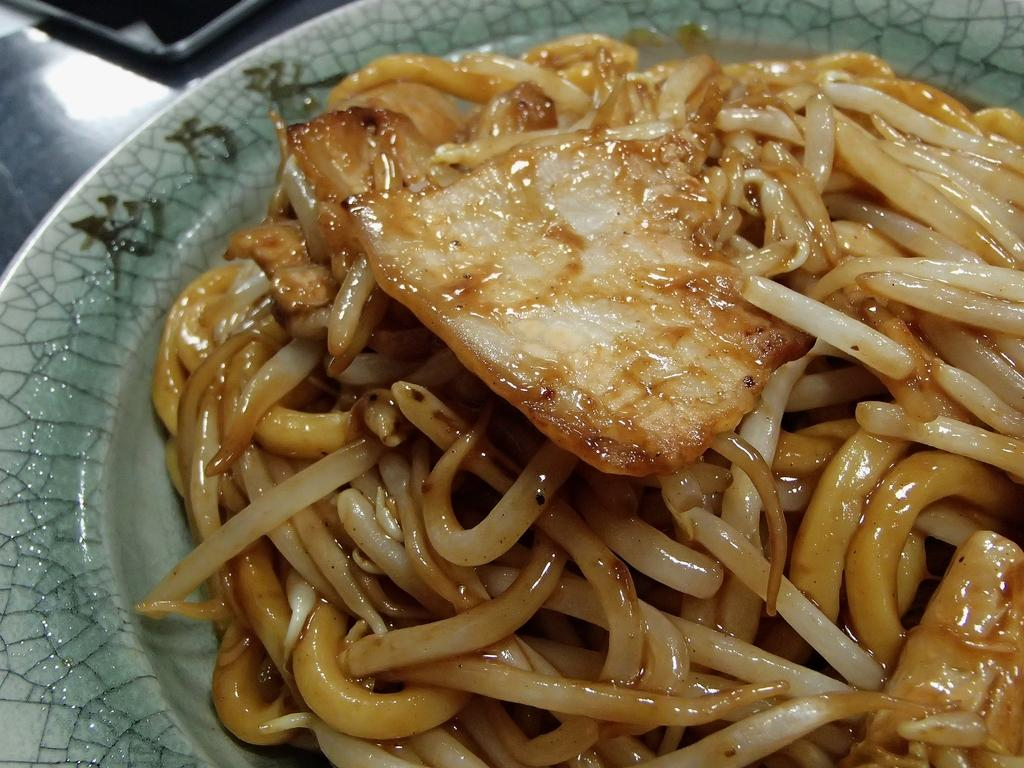What is on the plate in the image? There are noodles in the plate. Can you describe the main food item in the image? The main food item in the image is noodles. What type of sugar is being used to sweeten the noodles in the image? There is no sugar present in the image, as it features a plate with noodles. Can you see a toothbrush in the image? There is no toothbrush present in the image. 